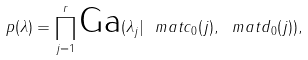<formula> <loc_0><loc_0><loc_500><loc_500>p ( \lambda ) = \prod _ { j = 1 } ^ { r } \text {Ga} ( \lambda _ { j } | \ m a t { c } _ { 0 } ( j ) , \ m a t { d } _ { 0 } ( j ) ) ,</formula> 